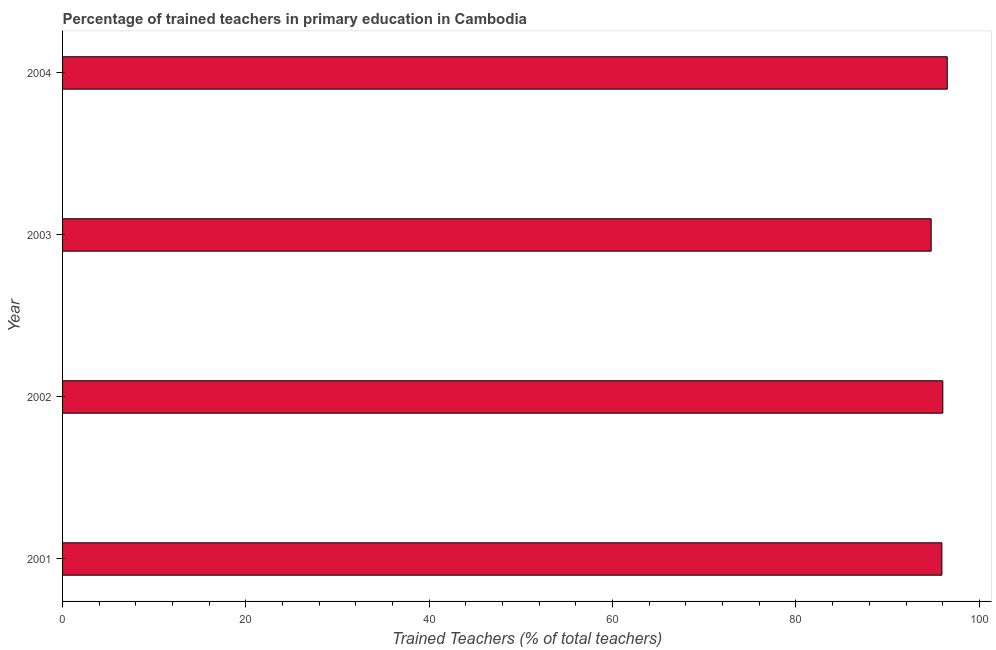Does the graph contain any zero values?
Keep it short and to the point. No. What is the title of the graph?
Your answer should be very brief. Percentage of trained teachers in primary education in Cambodia. What is the label or title of the X-axis?
Keep it short and to the point. Trained Teachers (% of total teachers). What is the percentage of trained teachers in 2004?
Your response must be concise. 96.5. Across all years, what is the maximum percentage of trained teachers?
Offer a terse response. 96.5. Across all years, what is the minimum percentage of trained teachers?
Your response must be concise. 94.75. In which year was the percentage of trained teachers minimum?
Make the answer very short. 2003. What is the sum of the percentage of trained teachers?
Provide a succinct answer. 383.18. What is the difference between the percentage of trained teachers in 2002 and 2003?
Ensure brevity in your answer.  1.27. What is the average percentage of trained teachers per year?
Provide a succinct answer. 95.79. What is the median percentage of trained teachers?
Your answer should be very brief. 95.97. Do a majority of the years between 2001 and 2004 (inclusive) have percentage of trained teachers greater than 40 %?
Offer a very short reply. Yes. What is the ratio of the percentage of trained teachers in 2001 to that in 2004?
Offer a terse response. 0.99. Is the percentage of trained teachers in 2002 less than that in 2004?
Your answer should be compact. Yes. What is the difference between the highest and the second highest percentage of trained teachers?
Make the answer very short. 0.48. Is the sum of the percentage of trained teachers in 2003 and 2004 greater than the maximum percentage of trained teachers across all years?
Offer a terse response. Yes. What is the difference between the highest and the lowest percentage of trained teachers?
Make the answer very short. 1.76. How many bars are there?
Your answer should be very brief. 4. Are all the bars in the graph horizontal?
Provide a succinct answer. Yes. How many years are there in the graph?
Give a very brief answer. 4. Are the values on the major ticks of X-axis written in scientific E-notation?
Offer a very short reply. No. What is the Trained Teachers (% of total teachers) in 2001?
Offer a terse response. 95.91. What is the Trained Teachers (% of total teachers) in 2002?
Your response must be concise. 96.02. What is the Trained Teachers (% of total teachers) in 2003?
Make the answer very short. 94.75. What is the Trained Teachers (% of total teachers) of 2004?
Give a very brief answer. 96.5. What is the difference between the Trained Teachers (% of total teachers) in 2001 and 2002?
Your response must be concise. -0.1. What is the difference between the Trained Teachers (% of total teachers) in 2001 and 2003?
Make the answer very short. 1.17. What is the difference between the Trained Teachers (% of total teachers) in 2001 and 2004?
Offer a terse response. -0.59. What is the difference between the Trained Teachers (% of total teachers) in 2002 and 2003?
Ensure brevity in your answer.  1.27. What is the difference between the Trained Teachers (% of total teachers) in 2002 and 2004?
Your response must be concise. -0.48. What is the difference between the Trained Teachers (% of total teachers) in 2003 and 2004?
Give a very brief answer. -1.76. What is the ratio of the Trained Teachers (% of total teachers) in 2001 to that in 2003?
Your response must be concise. 1.01. What is the ratio of the Trained Teachers (% of total teachers) in 2001 to that in 2004?
Ensure brevity in your answer.  0.99. 